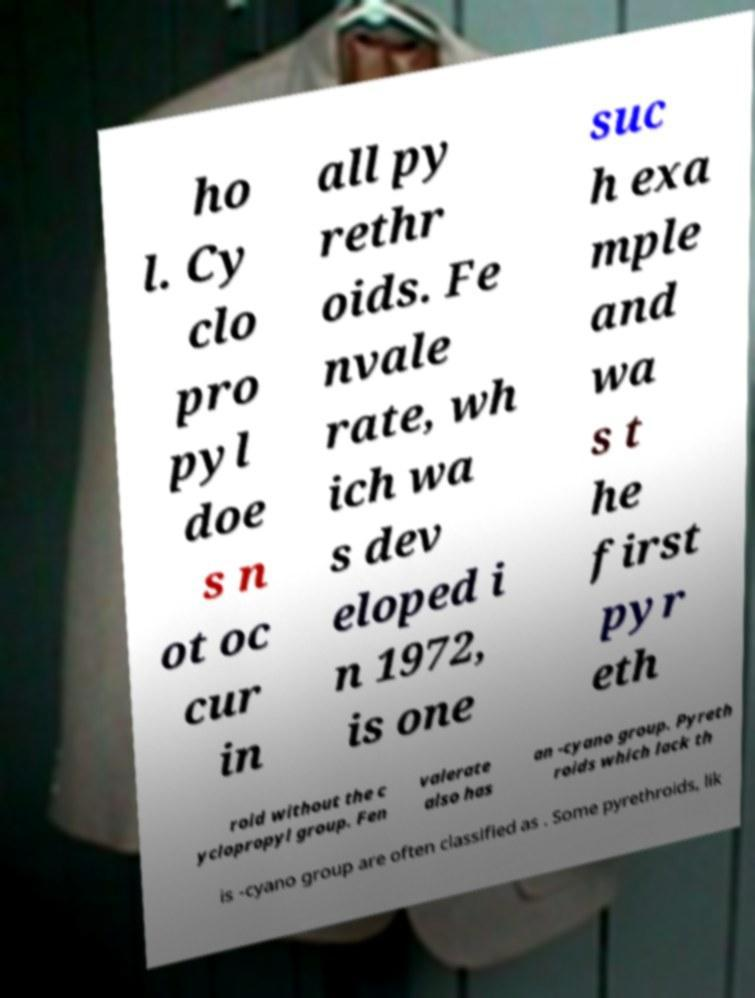Could you extract and type out the text from this image? ho l. Cy clo pro pyl doe s n ot oc cur in all py rethr oids. Fe nvale rate, wh ich wa s dev eloped i n 1972, is one suc h exa mple and wa s t he first pyr eth roid without the c yclopropyl group. Fen valerate also has an -cyano group. Pyreth roids which lack th is -cyano group are often classified as . Some pyrethroids, lik 